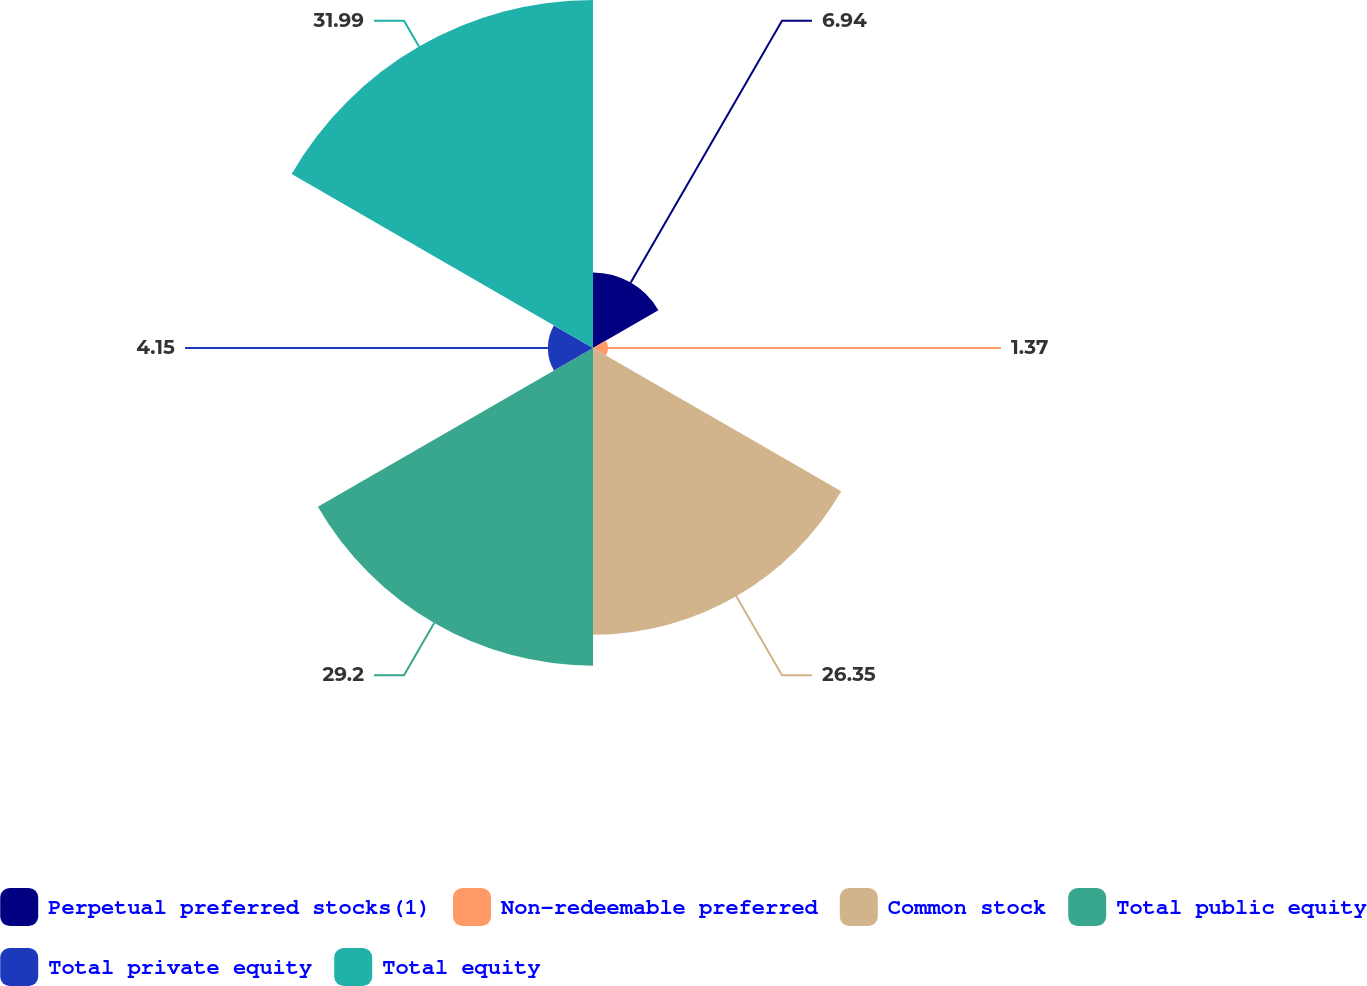Convert chart to OTSL. <chart><loc_0><loc_0><loc_500><loc_500><pie_chart><fcel>Perpetual preferred stocks(1)<fcel>Non-redeemable preferred<fcel>Common stock<fcel>Total public equity<fcel>Total private equity<fcel>Total equity<nl><fcel>6.94%<fcel>1.37%<fcel>26.35%<fcel>29.2%<fcel>4.15%<fcel>31.99%<nl></chart> 